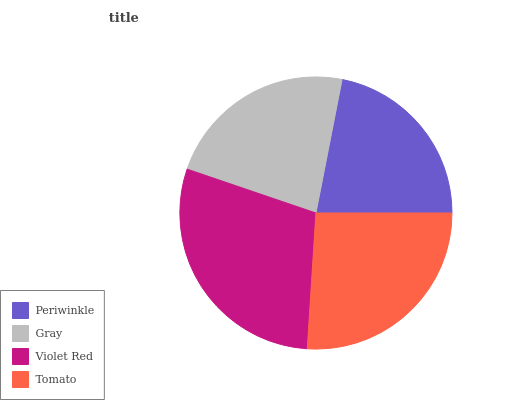Is Periwinkle the minimum?
Answer yes or no. Yes. Is Violet Red the maximum?
Answer yes or no. Yes. Is Gray the minimum?
Answer yes or no. No. Is Gray the maximum?
Answer yes or no. No. Is Gray greater than Periwinkle?
Answer yes or no. Yes. Is Periwinkle less than Gray?
Answer yes or no. Yes. Is Periwinkle greater than Gray?
Answer yes or no. No. Is Gray less than Periwinkle?
Answer yes or no. No. Is Tomato the high median?
Answer yes or no. Yes. Is Gray the low median?
Answer yes or no. Yes. Is Periwinkle the high median?
Answer yes or no. No. Is Periwinkle the low median?
Answer yes or no. No. 